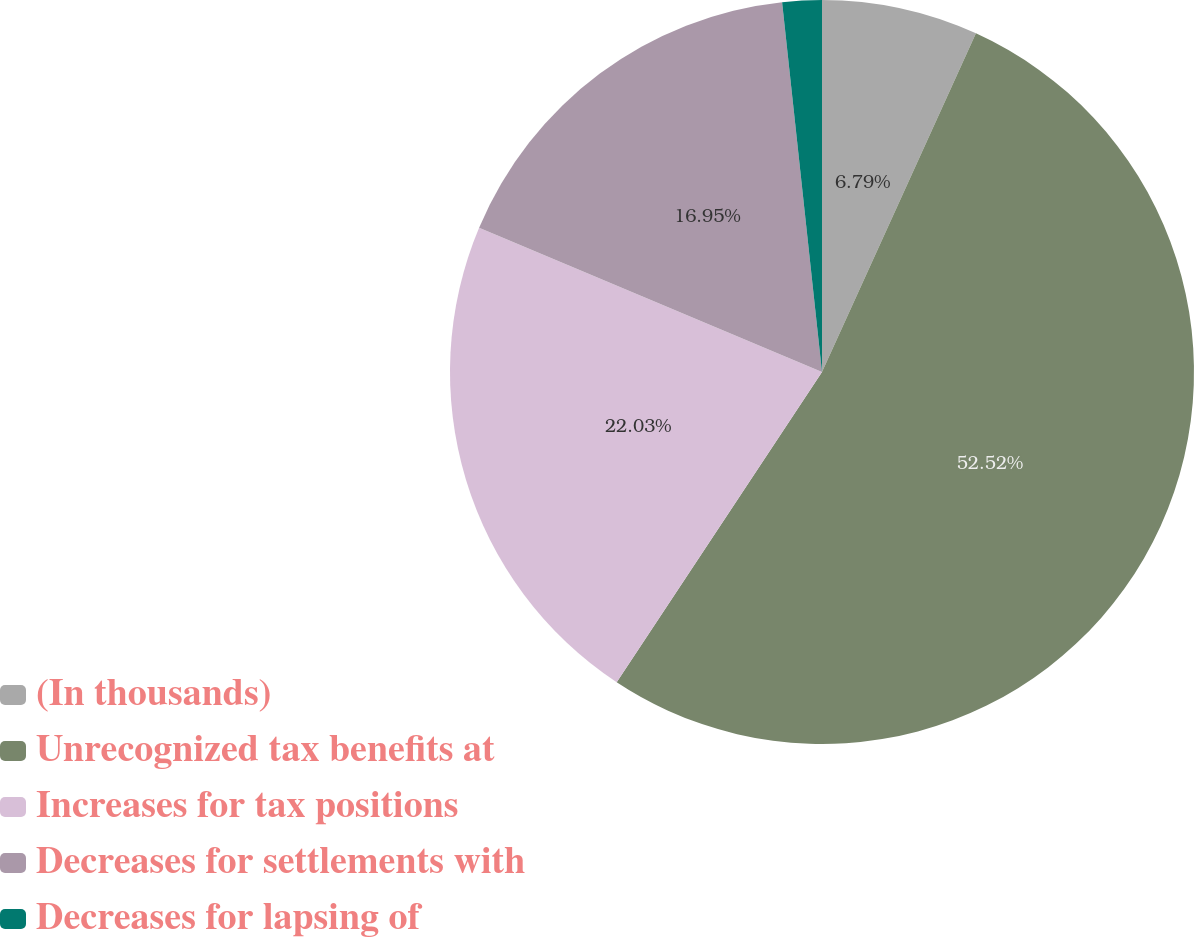Convert chart. <chart><loc_0><loc_0><loc_500><loc_500><pie_chart><fcel>(In thousands)<fcel>Unrecognized tax benefits at<fcel>Increases for tax positions<fcel>Decreases for settlements with<fcel>Decreases for lapsing of<nl><fcel>6.79%<fcel>52.51%<fcel>22.03%<fcel>16.95%<fcel>1.71%<nl></chart> 